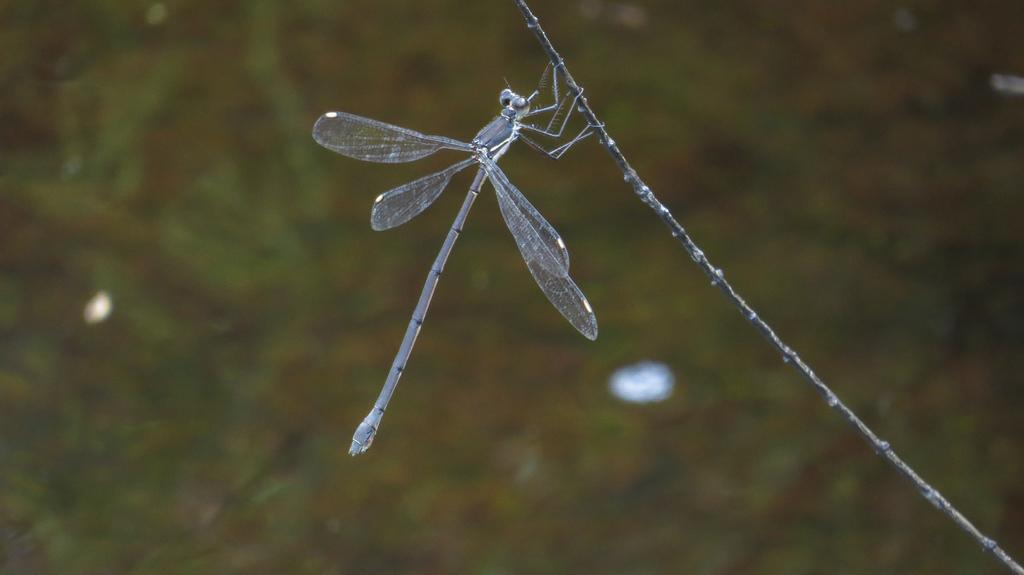What is present in the image that is small and has multiple legs? There is an insect in the image. What is the insect doing or resting on in the image? The insect is on a thread in the image. What color is the insect in the image? The insect is green in color. What direction is the dog facing in the image? There is no dog present in the image. 